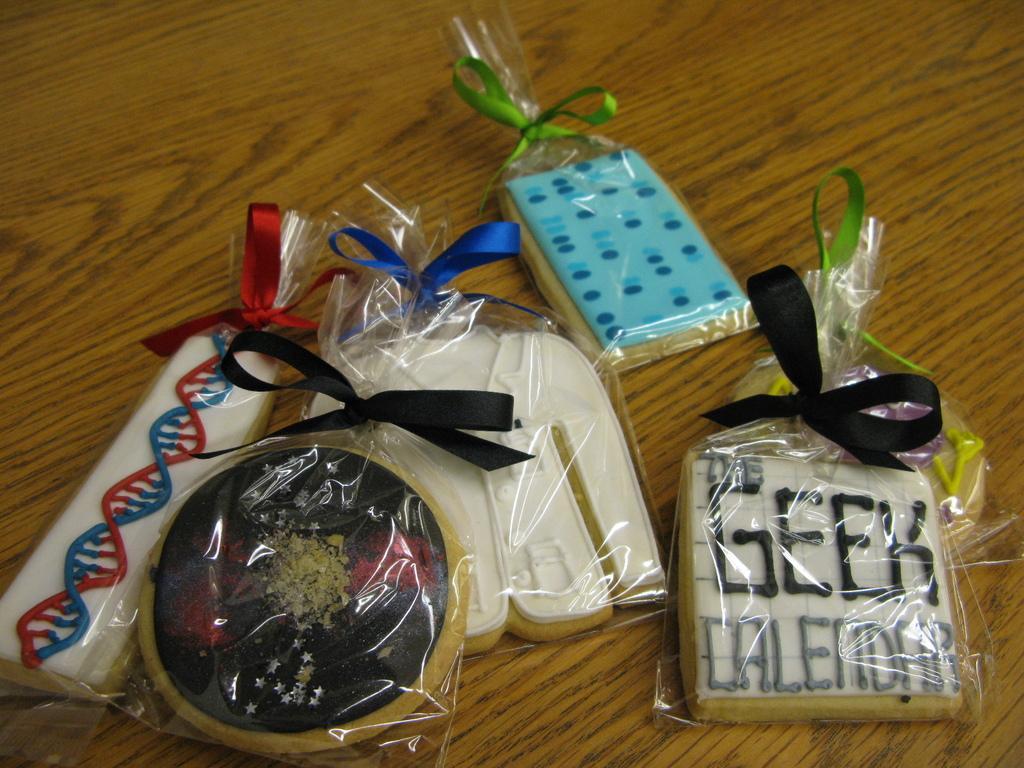In one or two sentences, can you explain what this image depicts? In the image there are some items kept on a table, they are of different shapes and sizes. 